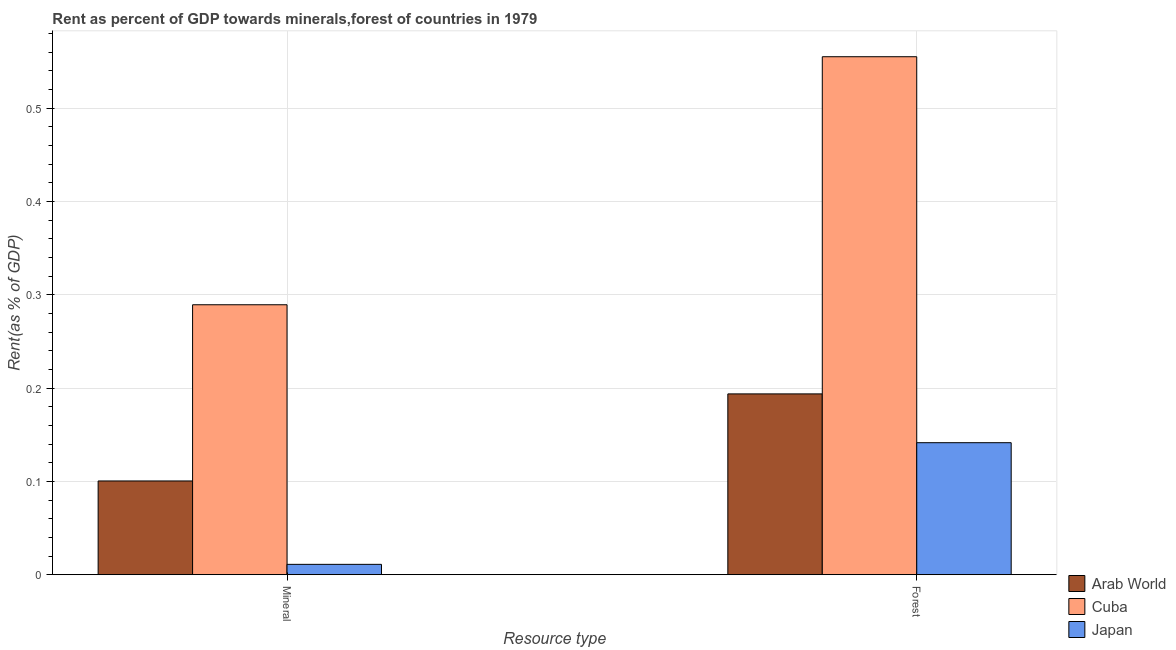How many different coloured bars are there?
Your answer should be compact. 3. Are the number of bars per tick equal to the number of legend labels?
Your response must be concise. Yes. Are the number of bars on each tick of the X-axis equal?
Provide a succinct answer. Yes. How many bars are there on the 2nd tick from the left?
Make the answer very short. 3. How many bars are there on the 2nd tick from the right?
Keep it short and to the point. 3. What is the label of the 2nd group of bars from the left?
Your response must be concise. Forest. What is the forest rent in Arab World?
Provide a succinct answer. 0.19. Across all countries, what is the maximum forest rent?
Provide a short and direct response. 0.56. Across all countries, what is the minimum mineral rent?
Your answer should be very brief. 0.01. In which country was the forest rent maximum?
Offer a very short reply. Cuba. In which country was the mineral rent minimum?
Your response must be concise. Japan. What is the total forest rent in the graph?
Give a very brief answer. 0.89. What is the difference between the forest rent in Japan and that in Arab World?
Your response must be concise. -0.05. What is the difference between the forest rent in Arab World and the mineral rent in Cuba?
Give a very brief answer. -0.1. What is the average mineral rent per country?
Keep it short and to the point. 0.13. What is the difference between the mineral rent and forest rent in Japan?
Give a very brief answer. -0.13. What is the ratio of the mineral rent in Cuba to that in Arab World?
Your answer should be compact. 2.88. What does the 1st bar from the left in Mineral represents?
Give a very brief answer. Arab World. What does the 1st bar from the right in Mineral represents?
Ensure brevity in your answer.  Japan. How many bars are there?
Provide a short and direct response. 6. What is the difference between two consecutive major ticks on the Y-axis?
Your response must be concise. 0.1. Are the values on the major ticks of Y-axis written in scientific E-notation?
Your response must be concise. No. Where does the legend appear in the graph?
Ensure brevity in your answer.  Bottom right. How many legend labels are there?
Provide a succinct answer. 3. How are the legend labels stacked?
Your answer should be very brief. Vertical. What is the title of the graph?
Your answer should be compact. Rent as percent of GDP towards minerals,forest of countries in 1979. What is the label or title of the X-axis?
Offer a terse response. Resource type. What is the label or title of the Y-axis?
Your answer should be very brief. Rent(as % of GDP). What is the Rent(as % of GDP) in Arab World in Mineral?
Your answer should be compact. 0.1. What is the Rent(as % of GDP) of Cuba in Mineral?
Keep it short and to the point. 0.29. What is the Rent(as % of GDP) of Japan in Mineral?
Your response must be concise. 0.01. What is the Rent(as % of GDP) of Arab World in Forest?
Your response must be concise. 0.19. What is the Rent(as % of GDP) of Cuba in Forest?
Your answer should be compact. 0.56. What is the Rent(as % of GDP) of Japan in Forest?
Keep it short and to the point. 0.14. Across all Resource type, what is the maximum Rent(as % of GDP) in Arab World?
Your answer should be compact. 0.19. Across all Resource type, what is the maximum Rent(as % of GDP) in Cuba?
Make the answer very short. 0.56. Across all Resource type, what is the maximum Rent(as % of GDP) in Japan?
Your answer should be compact. 0.14. Across all Resource type, what is the minimum Rent(as % of GDP) of Arab World?
Ensure brevity in your answer.  0.1. Across all Resource type, what is the minimum Rent(as % of GDP) of Cuba?
Provide a succinct answer. 0.29. Across all Resource type, what is the minimum Rent(as % of GDP) in Japan?
Keep it short and to the point. 0.01. What is the total Rent(as % of GDP) of Arab World in the graph?
Give a very brief answer. 0.29. What is the total Rent(as % of GDP) in Cuba in the graph?
Offer a very short reply. 0.84. What is the total Rent(as % of GDP) of Japan in the graph?
Offer a terse response. 0.15. What is the difference between the Rent(as % of GDP) of Arab World in Mineral and that in Forest?
Keep it short and to the point. -0.09. What is the difference between the Rent(as % of GDP) in Cuba in Mineral and that in Forest?
Your answer should be very brief. -0.27. What is the difference between the Rent(as % of GDP) of Japan in Mineral and that in Forest?
Ensure brevity in your answer.  -0.13. What is the difference between the Rent(as % of GDP) of Arab World in Mineral and the Rent(as % of GDP) of Cuba in Forest?
Provide a succinct answer. -0.45. What is the difference between the Rent(as % of GDP) in Arab World in Mineral and the Rent(as % of GDP) in Japan in Forest?
Keep it short and to the point. -0.04. What is the difference between the Rent(as % of GDP) of Cuba in Mineral and the Rent(as % of GDP) of Japan in Forest?
Offer a terse response. 0.15. What is the average Rent(as % of GDP) in Arab World per Resource type?
Offer a very short reply. 0.15. What is the average Rent(as % of GDP) in Cuba per Resource type?
Make the answer very short. 0.42. What is the average Rent(as % of GDP) in Japan per Resource type?
Keep it short and to the point. 0.08. What is the difference between the Rent(as % of GDP) of Arab World and Rent(as % of GDP) of Cuba in Mineral?
Provide a short and direct response. -0.19. What is the difference between the Rent(as % of GDP) of Arab World and Rent(as % of GDP) of Japan in Mineral?
Your answer should be compact. 0.09. What is the difference between the Rent(as % of GDP) in Cuba and Rent(as % of GDP) in Japan in Mineral?
Your response must be concise. 0.28. What is the difference between the Rent(as % of GDP) of Arab World and Rent(as % of GDP) of Cuba in Forest?
Make the answer very short. -0.36. What is the difference between the Rent(as % of GDP) in Arab World and Rent(as % of GDP) in Japan in Forest?
Keep it short and to the point. 0.05. What is the difference between the Rent(as % of GDP) in Cuba and Rent(as % of GDP) in Japan in Forest?
Give a very brief answer. 0.41. What is the ratio of the Rent(as % of GDP) of Arab World in Mineral to that in Forest?
Your answer should be compact. 0.52. What is the ratio of the Rent(as % of GDP) in Cuba in Mineral to that in Forest?
Keep it short and to the point. 0.52. What is the ratio of the Rent(as % of GDP) in Japan in Mineral to that in Forest?
Your answer should be very brief. 0.08. What is the difference between the highest and the second highest Rent(as % of GDP) in Arab World?
Your answer should be compact. 0.09. What is the difference between the highest and the second highest Rent(as % of GDP) of Cuba?
Your answer should be very brief. 0.27. What is the difference between the highest and the second highest Rent(as % of GDP) in Japan?
Offer a very short reply. 0.13. What is the difference between the highest and the lowest Rent(as % of GDP) in Arab World?
Your answer should be compact. 0.09. What is the difference between the highest and the lowest Rent(as % of GDP) of Cuba?
Give a very brief answer. 0.27. What is the difference between the highest and the lowest Rent(as % of GDP) of Japan?
Provide a succinct answer. 0.13. 